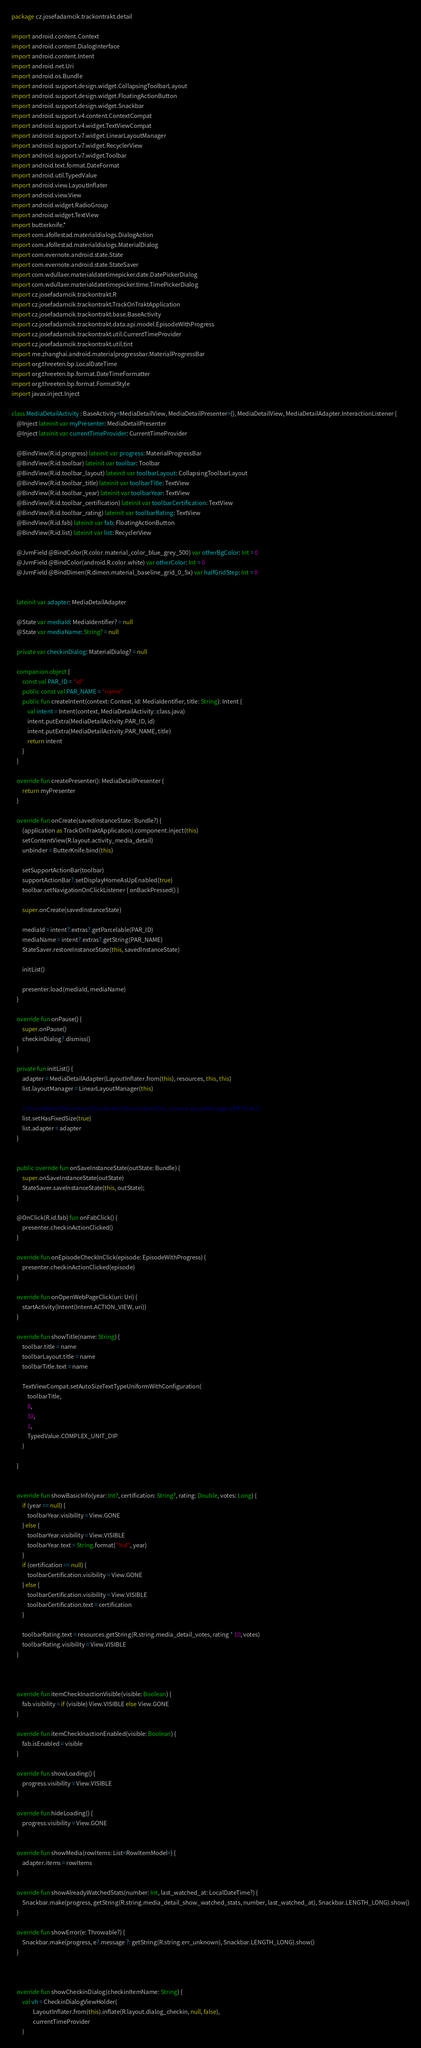<code> <loc_0><loc_0><loc_500><loc_500><_Kotlin_>package cz.josefadamcik.trackontrakt.detail

import android.content.Context
import android.content.DialogInterface
import android.content.Intent
import android.net.Uri
import android.os.Bundle
import android.support.design.widget.CollapsingToolbarLayout
import android.support.design.widget.FloatingActionButton
import android.support.design.widget.Snackbar
import android.support.v4.content.ContextCompat
import android.support.v4.widget.TextViewCompat
import android.support.v7.widget.LinearLayoutManager
import android.support.v7.widget.RecyclerView
import android.support.v7.widget.Toolbar
import android.text.format.DateFormat
import android.util.TypedValue
import android.view.LayoutInflater
import android.view.View
import android.widget.RadioGroup
import android.widget.TextView
import butterknife.*
import com.afollestad.materialdialogs.DialogAction
import com.afollestad.materialdialogs.MaterialDialog
import com.evernote.android.state.State
import com.evernote.android.state.StateSaver
import com.wdullaer.materialdatetimepicker.date.DatePickerDialog
import com.wdullaer.materialdatetimepicker.time.TimePickerDialog
import cz.josefadamcik.trackontrakt.R
import cz.josefadamcik.trackontrakt.TrackOnTraktApplication
import cz.josefadamcik.trackontrakt.base.BaseActivity
import cz.josefadamcik.trackontrakt.data.api.model.EpisodeWithProgress
import cz.josefadamcik.trackontrakt.util.CurrentTimeProvider
import cz.josefadamcik.trackontrakt.util.tint
import me.zhanghai.android.materialprogressbar.MaterialProgressBar
import org.threeten.bp.LocalDateTime
import org.threeten.bp.format.DateTimeFormatter
import org.threeten.bp.format.FormatStyle
import javax.inject.Inject

class MediaDetailActivity : BaseActivity<MediaDetailView, MediaDetailPresenter>(), MediaDetailView, MediaDetailAdapter.InteractionListener {
    @Inject lateinit var myPresenter: MediaDetailPresenter
    @Inject lateinit var currentTimeProvider: CurrentTimeProvider

    @BindView(R.id.progress) lateinit var progress: MaterialProgressBar
    @BindView(R.id.toolbar) lateinit var toolbar: Toolbar
    @BindView(R.id.toolbar_layout) lateinit var toolbarLayout: CollapsingToolbarLayout
    @BindView(R.id.toolbar_title) lateinit var toolbarTitle: TextView
    @BindView(R.id.toolbar_year) lateinit var toolbarYear: TextView
    @BindView(R.id.toolbar_certification) lateinit var toolbarCertification: TextView
    @BindView(R.id.toolbar_rating) lateinit var toolbarRating: TextView
    @BindView(R.id.fab) lateinit var fab: FloatingActionButton
    @BindView(R.id.list) lateinit var list: RecyclerView

    @JvmField @BindColor(R.color.material_color_blue_grey_500) var otherBgColor: Int = 0
    @JvmField @BindColor(android.R.color.white) var otherColor: Int = 0
    @JvmField @BindDimen(R.dimen.material_baseline_grid_0_5x) var halfGridStep: Int = 0


    lateinit var adapter: MediaDetailAdapter

    @State var mediaId: MediaIdentifier? = null
    @State var mediaName: String? = null

    private var checkinDialog: MaterialDialog? = null

    companion object {
        const val PAR_ID = "id"
        public const val PAR_NAME = "name"
        public fun createIntent(context: Context, id: MediaIdentifier, title: String): Intent {
            val intent = Intent(context, MediaDetailActivity::class.java)
            intent.putExtra(MediaDetailActivity.PAR_ID, id)
            intent.putExtra(MediaDetailActivity.PAR_NAME, title)
            return intent
        }
    }

    override fun createPresenter(): MediaDetailPresenter {
        return myPresenter
    }

    override fun onCreate(savedInstanceState: Bundle?) {
        (application as TrackOnTraktApplication).component.inject(this)
        setContentView(R.layout.activity_media_detail)
        unbinder = ButterKnife.bind(this)

        setSupportActionBar(toolbar)
        supportActionBar?.setDisplayHomeAsUpEnabled(true)
        toolbar.setNavigationOnClickListener { onBackPressed() }

        super.onCreate(savedInstanceState)

        mediaId = intent?.extras?.getParcelable(PAR_ID)
        mediaName = intent?.extras?.getString(PAR_NAME)
        StateSaver.restoreInstanceState(this, savedInstanceState)

        initList()

        presenter.load(mediaId, mediaName)
    }

    override fun onPause() {
        super.onPause()
        checkinDialog?.dismiss()
    }

    private fun initList() {
        adapter = MediaDetailAdapter(LayoutInflater.from(this), resources, this, this)
        list.layoutManager = LinearLayoutManager(this)

        //list.addItemDecoration(DividerItemDecoration(this, LinearLayoutManager.VERTICAL))
        list.setHasFixedSize(true)
        list.adapter = adapter
    }


    public override fun onSaveInstanceState(outState: Bundle) {
        super.onSaveInstanceState(outState)
        StateSaver.saveInstanceState(this, outState);
    }

    @OnClick(R.id.fab) fun onFabClick() {
        presenter.checkinActionClicked()
    }

    override fun onEpisodeCheckInClick(episode: EpisodeWithProgress) {
        presenter.checkinActionClicked(episode)
    }

    override fun onOpenWebPageClick(uri: Uri) {
        startActivity(Intent(Intent.ACTION_VIEW, uri))
    }

    override fun showTitle(name: String) {
        toolbar.title = name
        toolbarLayout.title = name
        toolbarTitle.text = name

        TextViewCompat.setAutoSizeTextTypeUniformWithConfiguration(
            toolbarTitle,
            8,
            32,
            1,
            TypedValue.COMPLEX_UNIT_DIP
        )

    }


    override fun showBasicInfo(year: Int?, certification: String?, rating: Double, votes: Long) {
        if (year == null) {
            toolbarYear.visibility = View.GONE
        } else {
            toolbarYear.visibility = View.VISIBLE
            toolbarYear.text = String.format("%d", year)
        }
        if (certification == null) {
            toolbarCertification.visibility = View.GONE
        } else {
            toolbarCertification.visibility = View.VISIBLE
            toolbarCertification.text = certification
        }

        toolbarRating.text = resources.getString(R.string.media_detail_votes, rating * 10, votes)
        toolbarRating.visibility = View.VISIBLE
    }



    override fun itemCheckInactionVisible(visible: Boolean) {
        fab.visibility = if (visible) View.VISIBLE else View.GONE
    }

    override fun itemCheckInactionEnabled(visible: Boolean) {
        fab.isEnabled = visible
    }

    override fun showLoading() {
        progress.visibility = View.VISIBLE
    }

    override fun hideLoading() {
        progress.visibility = View.GONE
    }

    override fun showMedia(rowItems: List<RowItemModel>) {
        adapter.items = rowItems
    }

    override fun showAlreadyWatchedStats(number: Int, last_watched_at: LocalDateTime?) {
        Snackbar.make(progress, getString(R.string.media_detail_show_watched_stats, number, last_watched_at), Snackbar.LENGTH_LONG).show()
    }

    override fun showError(e: Throwable?) {
        Snackbar.make(progress, e?.message ?: getString(R.string.err_unknown), Snackbar.LENGTH_LONG).show()
    }



    override fun showCheckinDialog(checkinItemName: String) {
        val vh = CheckinDialogViewHolder(
                LayoutInflater.from(this).inflate(R.layout.dialog_checkin, null, false),
                currentTimeProvider
        )</code> 